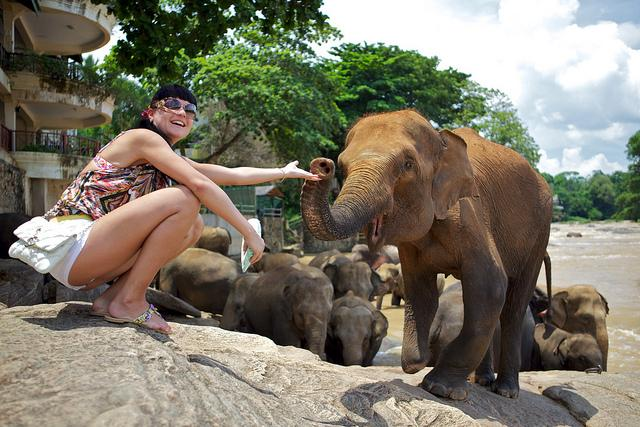What is the woman wearing? Please explain your reasoning. sandals. She has sandals on her feet. 